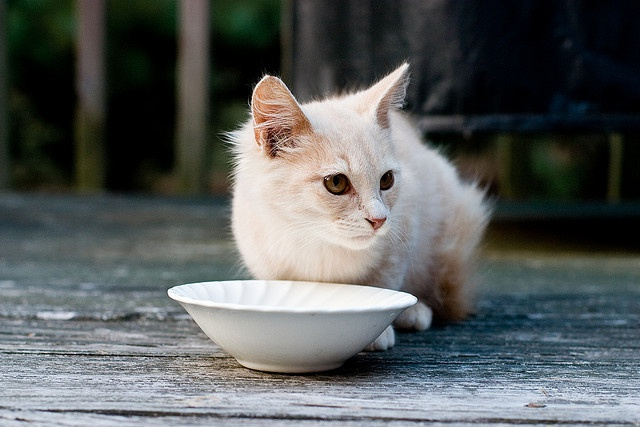Describe the objects in this image and their specific colors. I can see cat in black, lightgray, darkgray, gray, and tan tones and bowl in black, white, darkgray, gray, and lightgray tones in this image. 